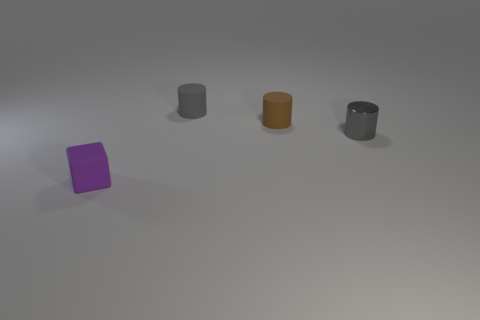The other cylinder that is the same material as the small brown cylinder is what color?
Make the answer very short. Gray. There is a tiny matte object that is in front of the small gray shiny cylinder; what color is it?
Make the answer very short. Purple. How many tiny metal things are the same color as the block?
Offer a very short reply. 0. Is the number of purple objects that are in front of the gray matte object less than the number of gray things to the right of the tiny gray metallic thing?
Give a very brief answer. No. There is a brown rubber object; what number of purple matte blocks are right of it?
Your response must be concise. 0. Is there a large green cylinder that has the same material as the block?
Provide a succinct answer. No. Are there more small rubber blocks that are right of the small gray matte object than tiny blocks that are to the left of the cube?
Make the answer very short. No. The brown thing has what size?
Your answer should be very brief. Small. There is a tiny gray object that is left of the small gray metal thing; what shape is it?
Your response must be concise. Cylinder. Is the shape of the gray shiny object the same as the brown rubber thing?
Give a very brief answer. Yes. 